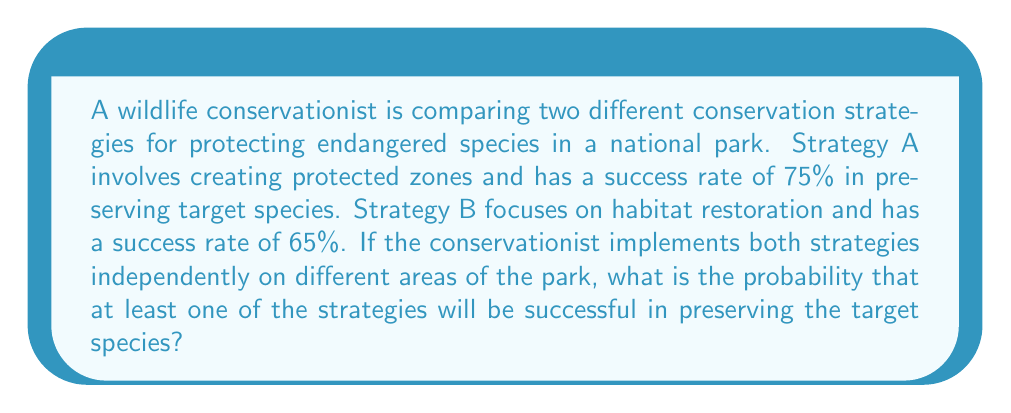Could you help me with this problem? Let's approach this step-by-step using probability theory:

1) First, we need to understand what the question is asking. We're looking for the probability that at least one strategy succeeds, which is equivalent to 1 minus the probability that both strategies fail.

2) Let's define our events:
   A: Strategy A succeeds (probability = 0.75)
   B: Strategy B succeeds (probability = 0.65)

3) We want to find P(A or B), which can be calculated using the complement rule:
   P(A or B) = 1 - P(neither A nor B)

4) Since the strategies are implemented independently, we can use the multiplication rule for independent events:
   P(neither A nor B) = P(not A) * P(not B)

5) We can calculate P(not A) and P(not B):
   P(not A) = 1 - P(A) = 1 - 0.75 = 0.25
   P(not B) = 1 - P(B) = 1 - 0.65 = 0.35

6) Now we can calculate:
   P(neither A nor B) = 0.25 * 0.35 = 0.0875

7) Finally, we can find our answer:
   P(A or B) = 1 - P(neither A nor B)
              = 1 - 0.0875
              = 0.9125

8) Convert to a percentage:
   0.9125 * 100 = 91.25%

Therefore, the probability that at least one of the strategies will be successful is 91.25%.
Answer: 91.25% 